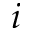<formula> <loc_0><loc_0><loc_500><loc_500>i</formula> 